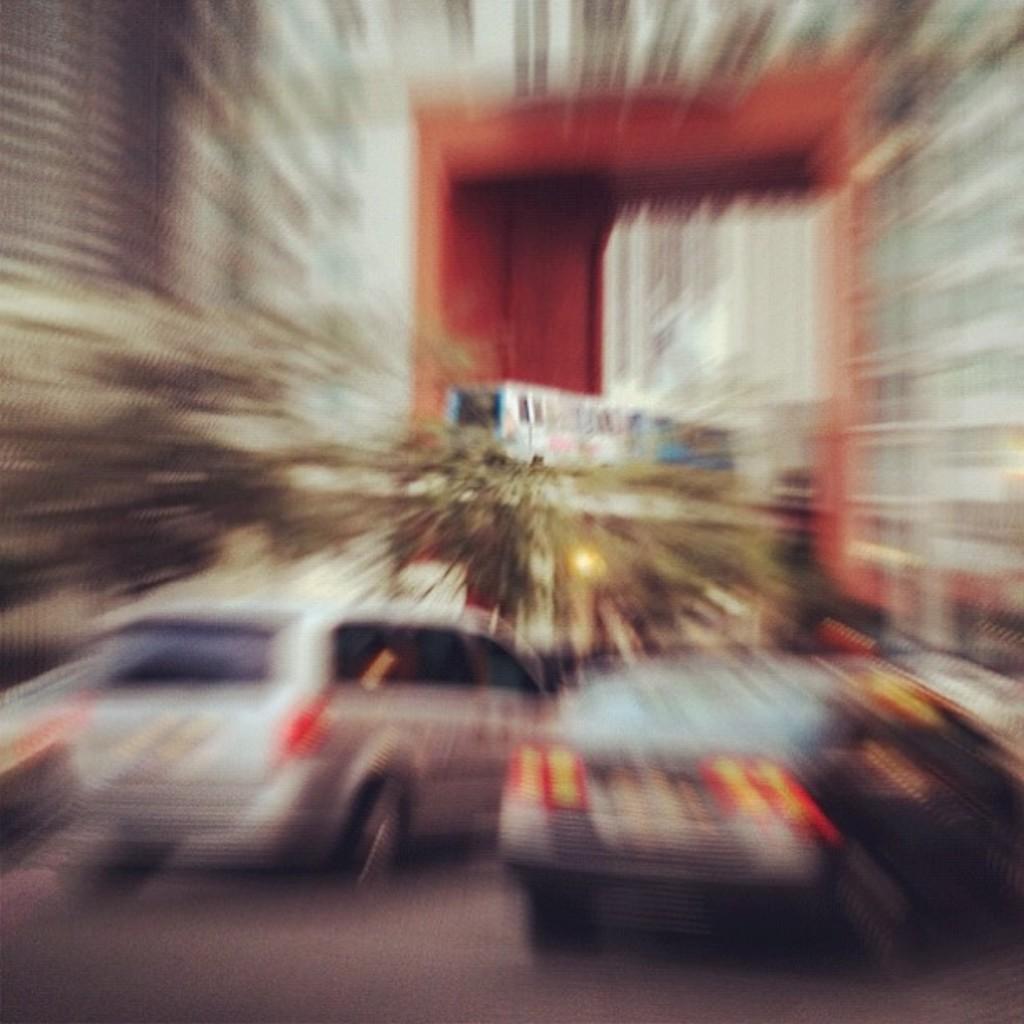In one or two sentences, can you explain what this image depicts? In this image we can see buildings, motor vehicles on the road, creepers and a train on the track. 